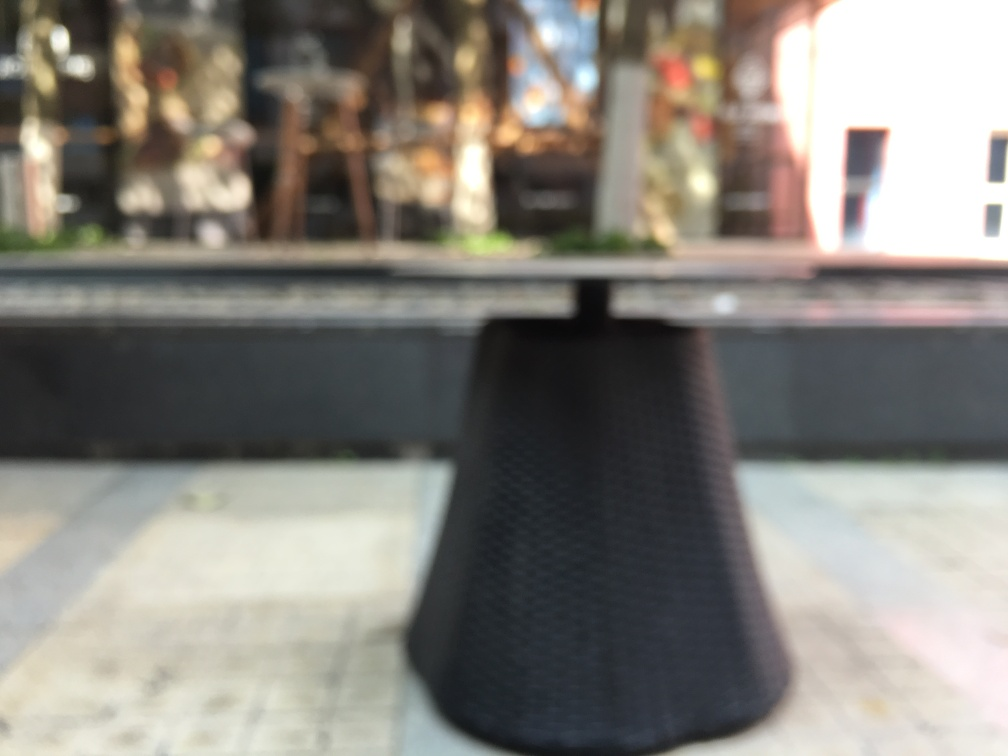Has the main subject, the table, lost a significant amount of texture detail?
A. Yes
B. No
Answer with the option's letter from the given choices directly.
 A. 